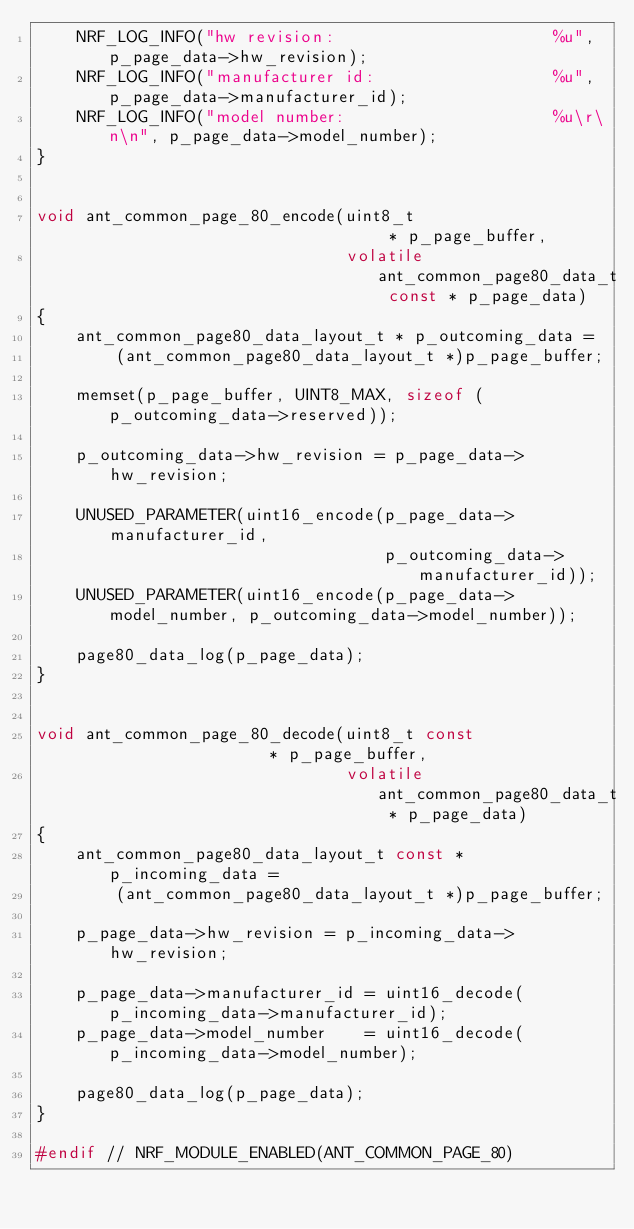<code> <loc_0><loc_0><loc_500><loc_500><_C_>    NRF_LOG_INFO("hw revision:                      %u", p_page_data->hw_revision);
    NRF_LOG_INFO("manufacturer id:                  %u", p_page_data->manufacturer_id);
    NRF_LOG_INFO("model number:                     %u\r\n\n", p_page_data->model_number);
}


void ant_common_page_80_encode(uint8_t                                 * p_page_buffer,
                               volatile ant_common_page80_data_t const * p_page_data)
{
    ant_common_page80_data_layout_t * p_outcoming_data =
        (ant_common_page80_data_layout_t *)p_page_buffer;

    memset(p_page_buffer, UINT8_MAX, sizeof (p_outcoming_data->reserved));

    p_outcoming_data->hw_revision = p_page_data->hw_revision;

    UNUSED_PARAMETER(uint16_encode(p_page_data->manufacturer_id,
                                   p_outcoming_data->manufacturer_id));
    UNUSED_PARAMETER(uint16_encode(p_page_data->model_number, p_outcoming_data->model_number));

    page80_data_log(p_page_data);
}


void ant_common_page_80_decode(uint8_t const                     * p_page_buffer,
                               volatile ant_common_page80_data_t * p_page_data)
{
    ant_common_page80_data_layout_t const * p_incoming_data =
        (ant_common_page80_data_layout_t *)p_page_buffer;

    p_page_data->hw_revision = p_incoming_data->hw_revision;

    p_page_data->manufacturer_id = uint16_decode(p_incoming_data->manufacturer_id);
    p_page_data->model_number    = uint16_decode(p_incoming_data->model_number);

    page80_data_log(p_page_data);
}

#endif // NRF_MODULE_ENABLED(ANT_COMMON_PAGE_80)
</code> 